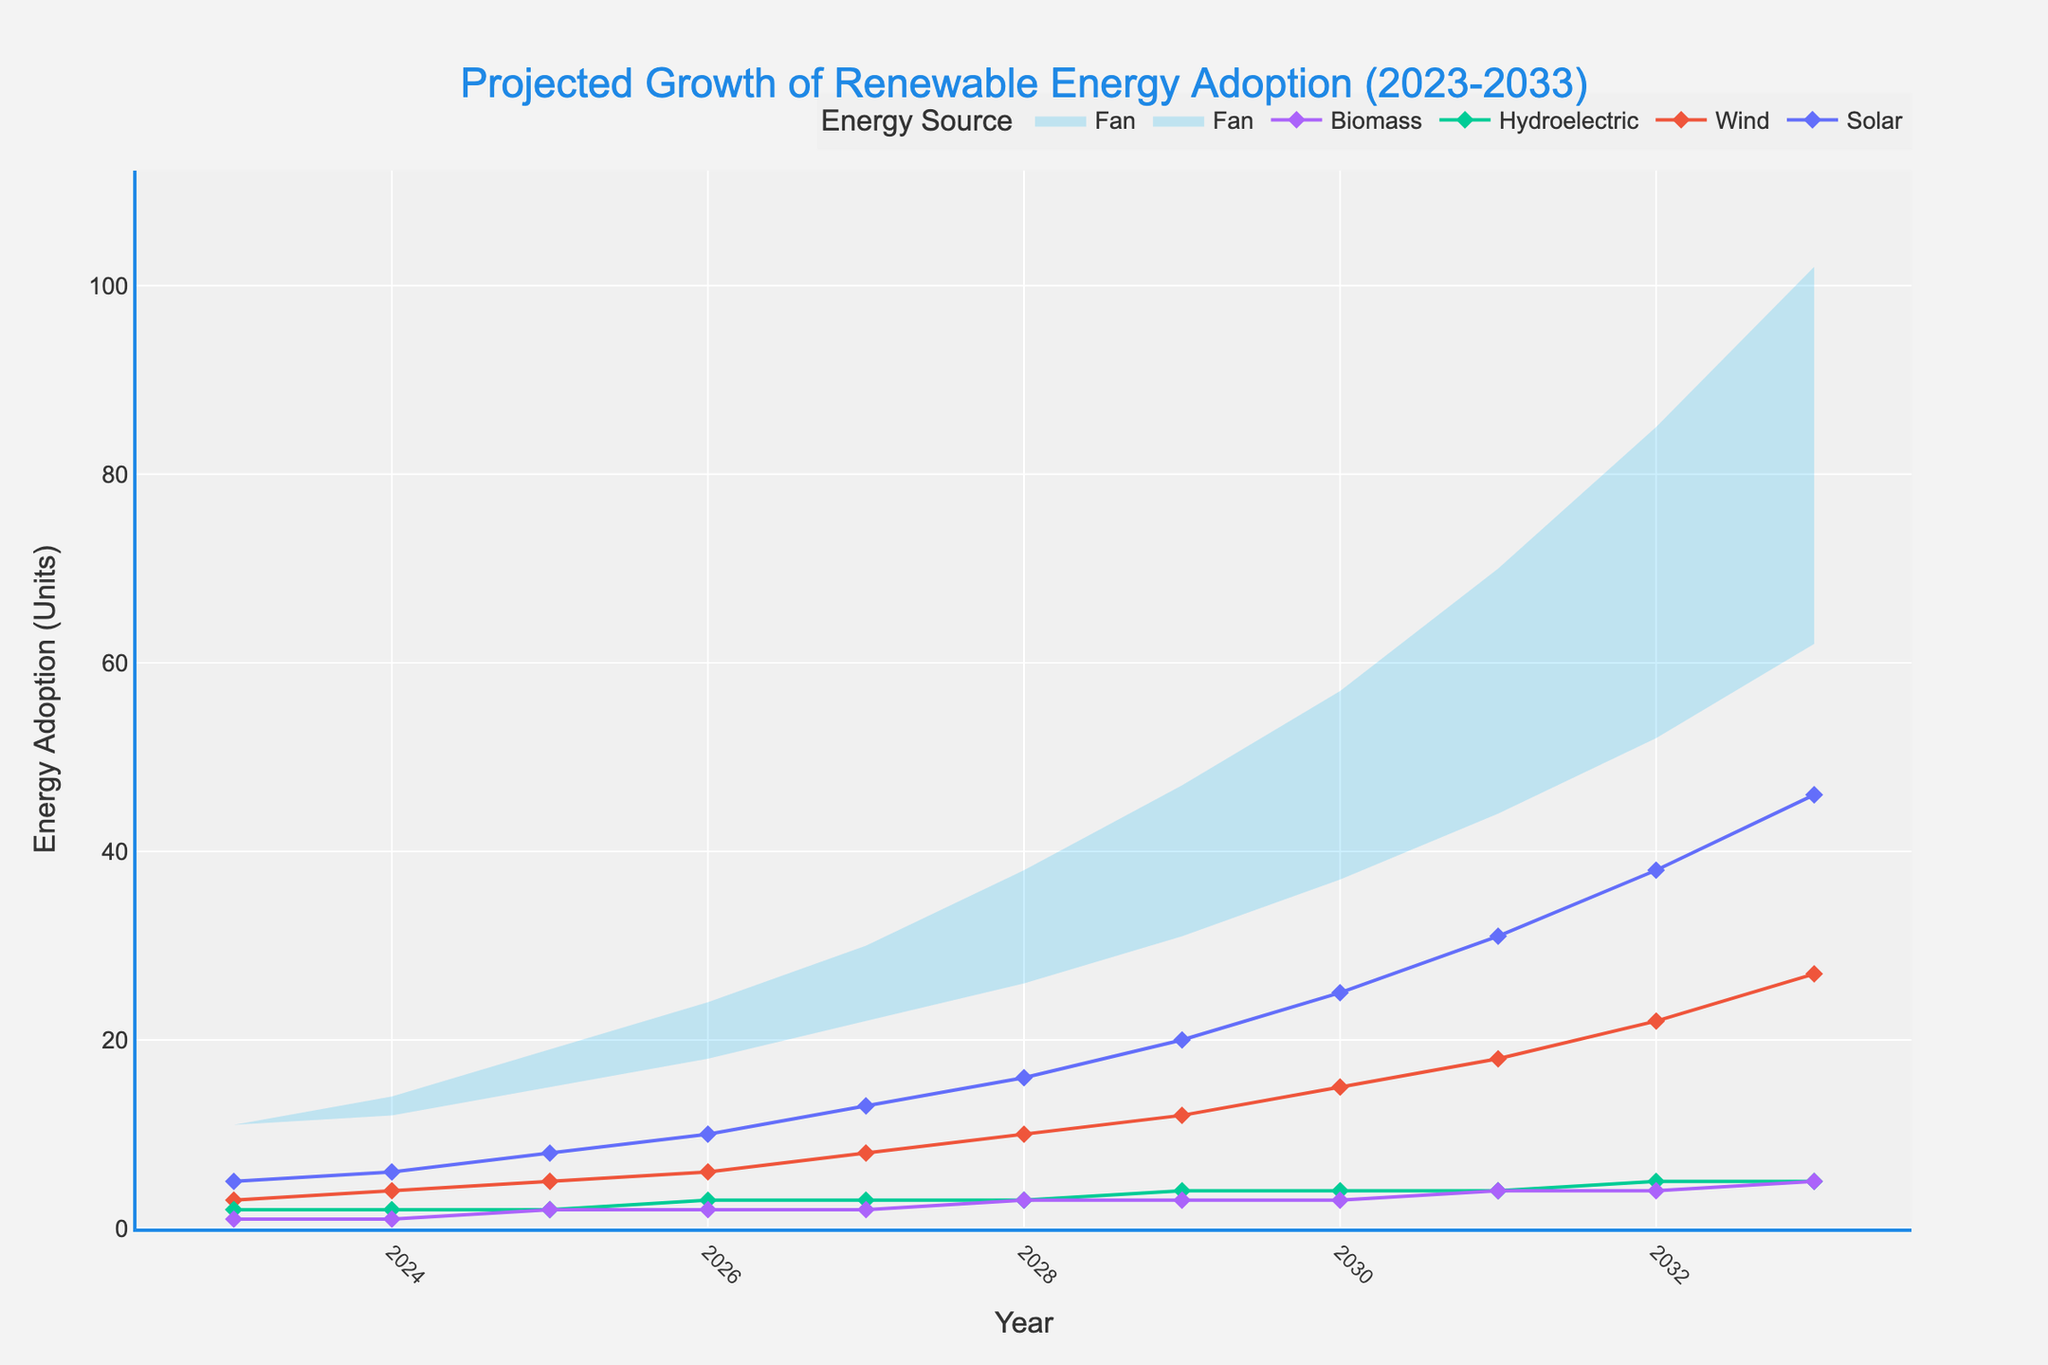what is the title of the chart? The title is found at the top of the chart, often in larger or bold font compared to other text in the figure.
Answer: Projected Growth of Renewable Energy Adoption (2023-2033) Which energy source shows the highest adoption in 2033? By looking at the lines for each energy source in the figure at the year 2033, you can compare their values.
Answer: Solar How does the adoption of Wind energy in 2025 compare to that in 2027? Locate the Wind energy values for 2025 and 2027 and compare the two numbers.
Answer: 5 in 2025 and 8 in 2027 What is the total projected adoption for all energy sources combined in 2028? Add the values of Solar, Wind, Hydroelectric, and Biomass for the year 2028.
Answer: 32 Between which years does Biomass energy adoption remain constant? Find the years where the Biomass values do not change.
Answer: 2023-2024 and 2029-2033 In which year does Hydroelectric energy see its first increase from the previous year? Observe the Hydroelectric values and pinpoint the first year where there is an increase compared to the previous year.
Answer: 2026 Which year has the highest maximum projected energy adoption according to the fan chart? Look at the 'High' values in the fan chart and identify the year with the highest value.
Answer: 2033 How much is the projected increase in Solar energy from 2023 to 2030? Subtract the Solar energy value in 2023 from the Solar energy value in 2030.
Answer: 20 